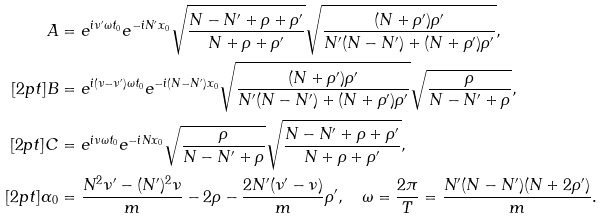Convert formula to latex. <formula><loc_0><loc_0><loc_500><loc_500>A & = e ^ { i \nu ^ { \prime } \omega t _ { 0 } } e ^ { - i N ^ { \prime } x _ { 0 } } \sqrt { \frac { N - N ^ { \prime } + \rho + \rho ^ { \prime } } { N + \rho + \rho ^ { \prime } } } \sqrt { \frac { ( N + \rho ^ { \prime } ) \rho ^ { \prime } } { N ^ { \prime } ( N - N ^ { \prime } ) + ( N + \rho ^ { \prime } ) \rho ^ { \prime } } } , \\ [ 2 p t ] B & = e ^ { i ( \nu - \nu ^ { \prime } ) \omega t _ { 0 } } e ^ { - i ( N - N ^ { \prime } ) x _ { 0 } } \sqrt { \frac { ( N + \rho ^ { \prime } ) \rho ^ { \prime } } { N ^ { \prime } ( N - N ^ { \prime } ) + ( N + \rho ^ { \prime } ) \rho ^ { \prime } } } \sqrt { \frac { \rho } { N - N ^ { \prime } + \rho } } , \quad \\ [ 2 p t ] C & = e ^ { i \nu \omega t _ { 0 } } e ^ { - i N x _ { 0 } } \sqrt { \frac { \rho } { N - N ^ { \prime } + \rho } } \sqrt { \frac { N - N ^ { \prime } + \rho + \rho ^ { \prime } } { N + \rho + \rho ^ { \prime } } } , \\ [ 2 p t ] \alpha _ { 0 } & = \frac { N ^ { 2 } \nu ^ { \prime } - ( N ^ { \prime } ) ^ { 2 } \nu } { m } - 2 \rho - \frac { 2 N ^ { \prime } ( \nu ^ { \prime } - \nu ) } { m } \rho ^ { \prime } , \quad \omega = \frac { 2 \pi } { T } = \frac { N ^ { \prime } ( N - N ^ { \prime } ) ( N + 2 \rho ^ { \prime } ) } { m } .</formula> 